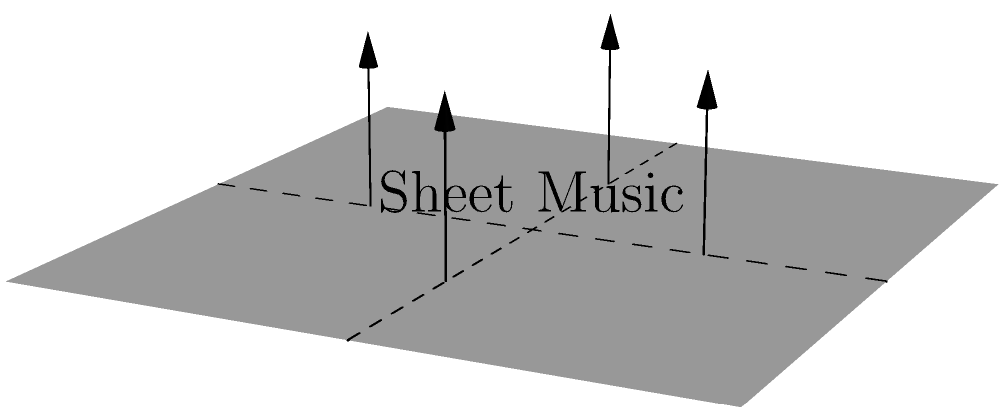As a classical singer, you're given a square sheet of music paper. If you fold this sheet along the dashed lines shown in the diagram, what three-dimensional shape will you create? Let's approach this step-by-step:

1. We start with a square sheet of music paper, as shown in the diagram.

2. The dashed lines indicate where the sheet should be folded. There are two lines: one vertical and one horizontal, both passing through the center of the square.

3. These fold lines divide the square into four equal smaller squares.

4. The arrows in the diagram indicate that all four corners should be folded upwards.

5. When we fold along these lines, each of the four smaller squares will form one face of the resulting 3D shape.

6. As all four corners are being folded upwards to meet at a single point, and the base remains square, the resulting shape will have:
   - A square base
   - Four triangular faces, each formed by folding up one of the smaller squares

7. This description matches the properties of a square-based pyramid.

Therefore, folding the sheet as indicated will result in a square-based pyramid.
Answer: Square-based pyramid 